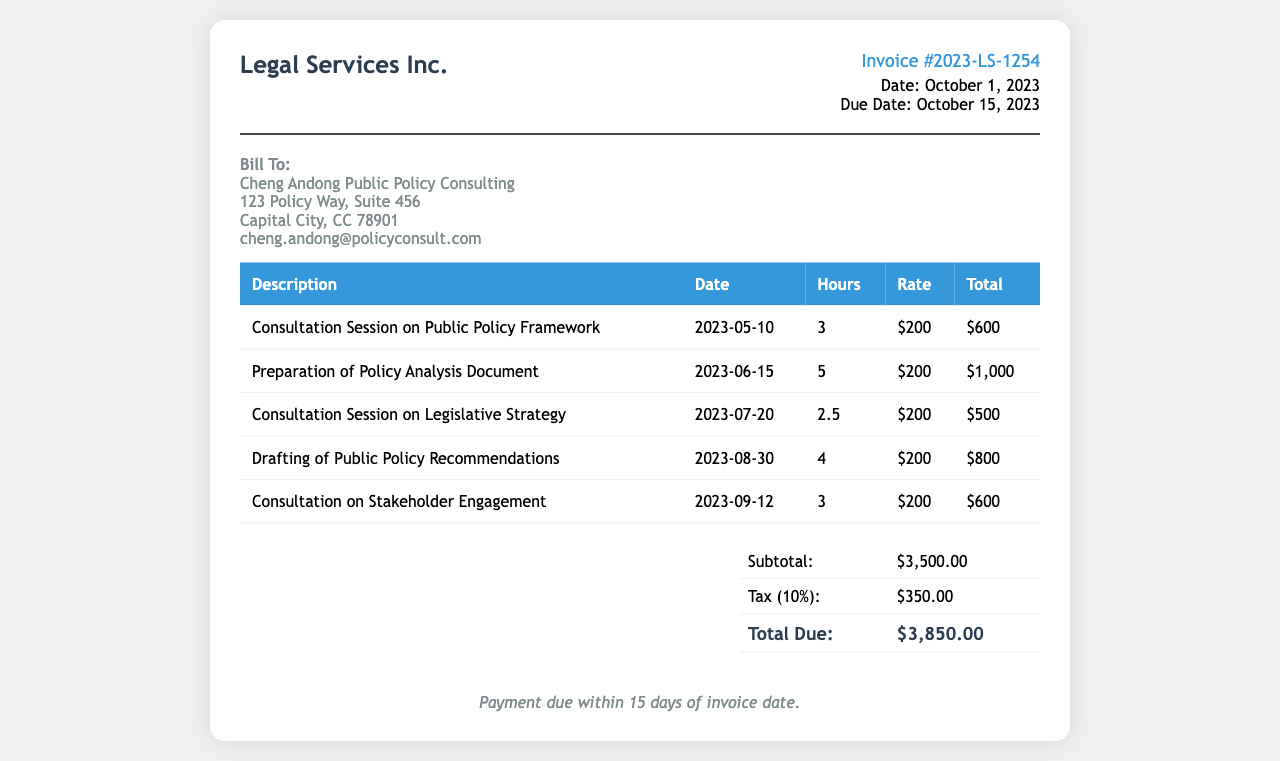What is the invoice number? The invoice number is listed at the top of the document under the invoice details section.
Answer: Invoice #2023-LS-1254 What is the due date for the invoice? The due date is provided in the invoice details section next to the date of issue.
Answer: October 15, 2023 Who is the invoice billed to? The billing address is found in the "Bill To" section at the bottom of the header.
Answer: Cheng Andong Public Policy Consulting How many hours were billed for the preparation of the policy analysis document? This information can be found in the table containing the billing details for each service provided.
Answer: 5 What is the subtotal amount before tax? The subtotal can be found in the summary table towards the end of the document.
Answer: $3,500.00 What was the tax rate applied in the invoice? The tax rate is mentioned in the summary table just before the total due amount.
Answer: 10% What is the total amount due? This figure is clearly stated in the summary table as the final amount owed.
Answer: $3,850.00 How many consultation sessions are listed in the document? The number of consultation sessions can be determined by counting the relevant rows in the service table.
Answer: 3 What is the payment term specified in the document? The payment term is mentioned at the bottom of the invoice under "Payment Terms."
Answer: Payment due within 15 days of invoice date 